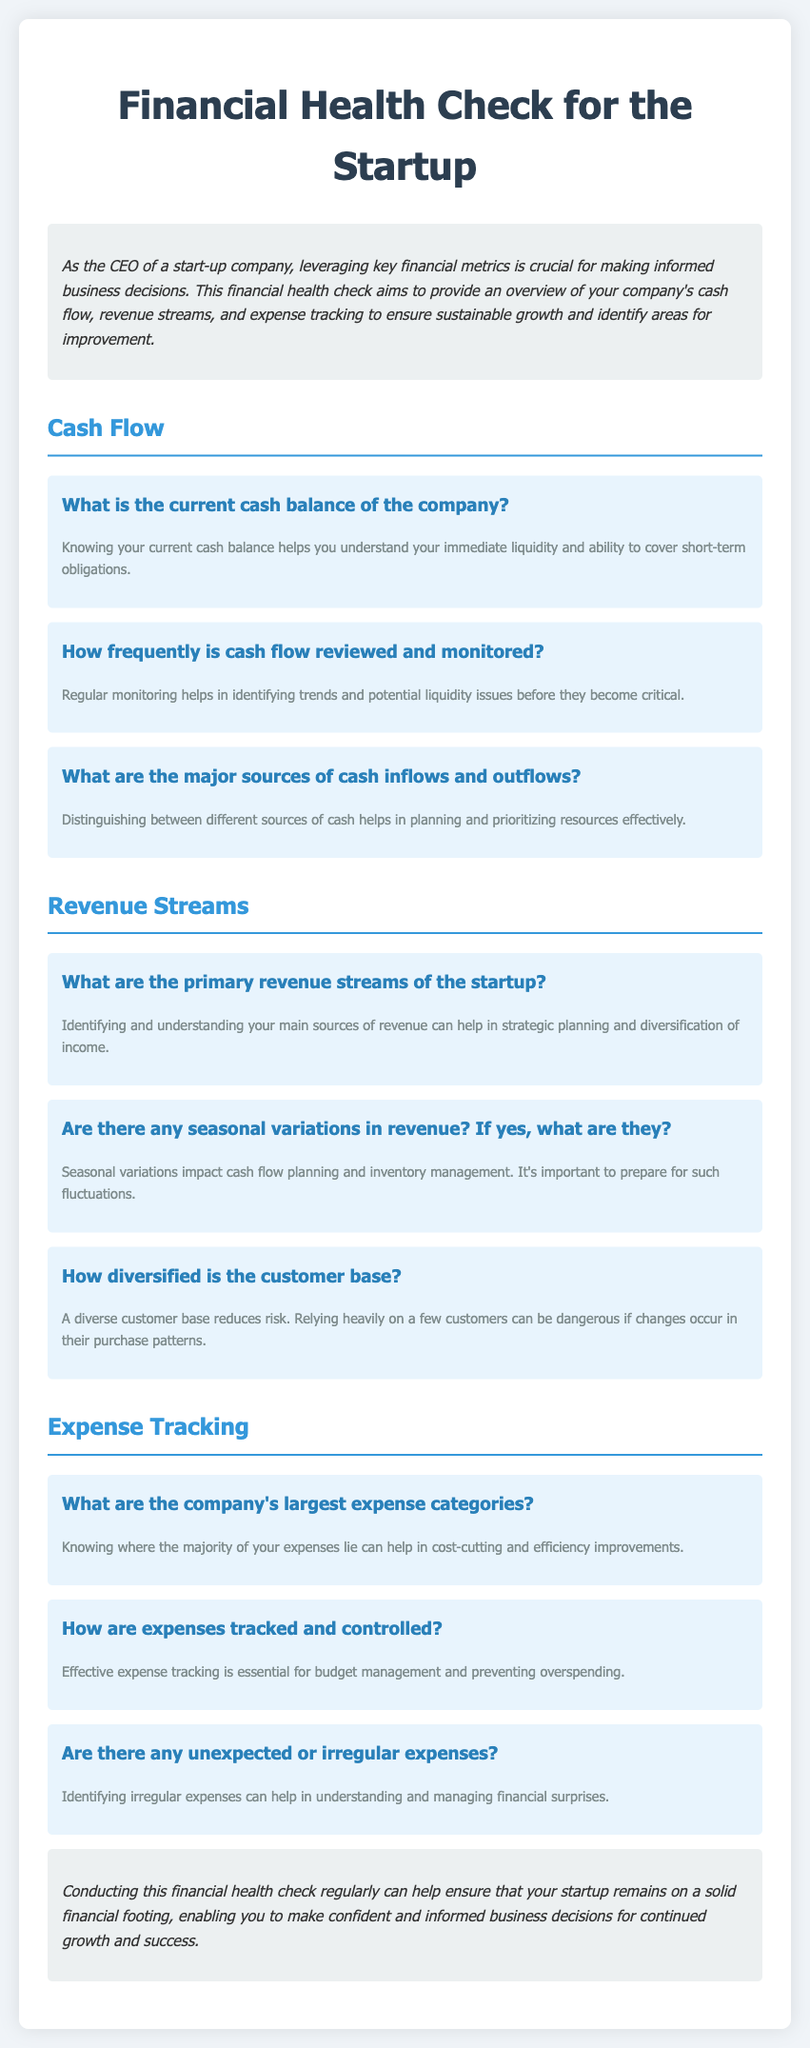What is the current cash balance of the company? Knowing your current cash balance helps you understand your immediate liquidity and ability to cover short-term obligations.
Answer: Current cash balance How frequently is cash flow reviewed and monitored? Regular monitoring helps in identifying trends and potential liquidity issues before they become critical.
Answer: Frequency of review What are the primary revenue streams of the startup? Identifying and understanding your main sources of revenue can help in strategic planning and diversification of income.
Answer: Primary revenue streams What are the company's largest expense categories? Knowing where the majority of your expenses lie can help in cost-cutting and efficiency improvements.
Answer: Largest expense categories How are expenses tracked and controlled? Effective expense tracking is essential for budget management and preventing overspending.
Answer: Expense tracking method 